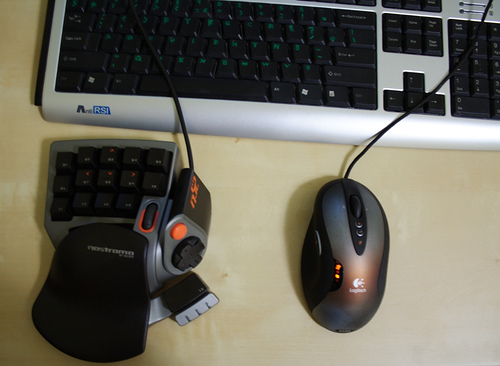<image>What letters/numbers appear on the keyboard at the bottom left? It is unclear what letters/numbers appear on the keyboard at the bottom left. It can be 'rs 1', '1 9 numerical keypad', '123', 'numeric keypad', or 'antirsi'. What letters/numbers appear on the keyboard at the bottom left? I don't know what letters/numbers appear on the keyboard at the bottom left. It can be seen 'rs 1', 'numbers 1 0', 'rsi', '1 9 numerical keypad', '123', 'unclear', 'numeric keypad' or 'antirsi'. 